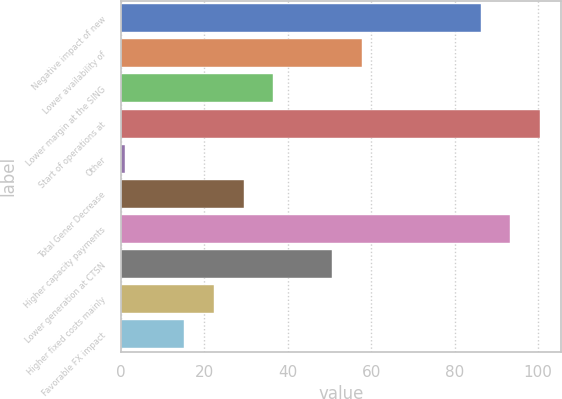Convert chart to OTSL. <chart><loc_0><loc_0><loc_500><loc_500><bar_chart><fcel>Negative impact of new<fcel>Lower availability of<fcel>Lower margin at the SING<fcel>Start of operations at<fcel>Other<fcel>Total Gener Decrease<fcel>Higher capacity payments<fcel>Lower generation at CTSN<fcel>Higher fixed costs mainly<fcel>Favorable FX impact<nl><fcel>86.2<fcel>57.8<fcel>36.5<fcel>100.4<fcel>1<fcel>29.4<fcel>93.3<fcel>50.7<fcel>22.3<fcel>15.2<nl></chart> 